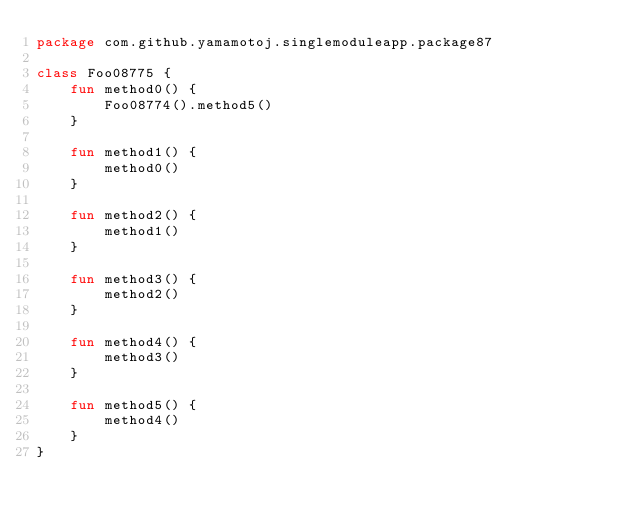Convert code to text. <code><loc_0><loc_0><loc_500><loc_500><_Kotlin_>package com.github.yamamotoj.singlemoduleapp.package87

class Foo08775 {
    fun method0() {
        Foo08774().method5()
    }

    fun method1() {
        method0()
    }

    fun method2() {
        method1()
    }

    fun method3() {
        method2()
    }

    fun method4() {
        method3()
    }

    fun method5() {
        method4()
    }
}
</code> 